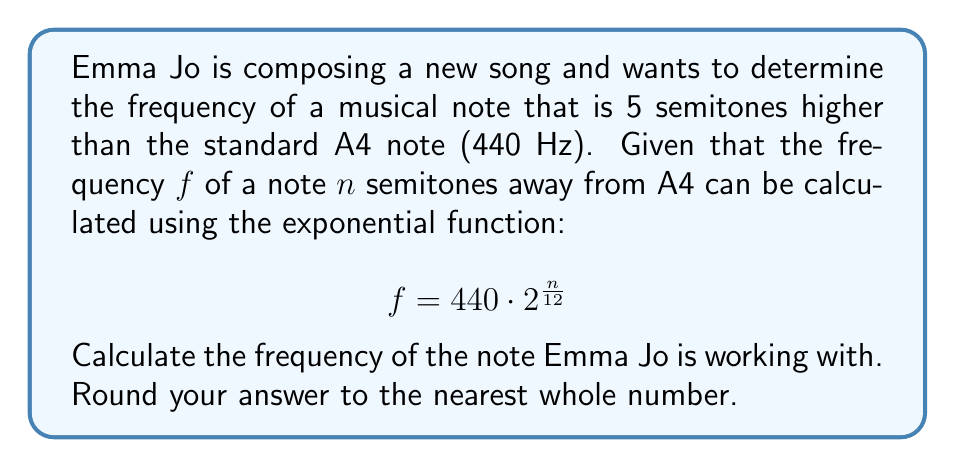Help me with this question. To solve this problem, we'll follow these steps:

1) We're given the exponential function for calculating the frequency:
   $$ f = 440 \cdot 2^{\frac{n}{12}} $$

2) We know that $n = 5$, as the note is 5 semitones higher than A4.

3) Let's substitute this value into our equation:
   $$ f = 440 \cdot 2^{\frac{5}{12}} $$

4) Now, let's calculate this step by step:
   
   a) First, let's calculate $\frac{5}{12}$:
      $\frac{5}{12} \approx 0.4166667$

   b) Now, let's calculate $2^{0.4166667}$:
      $2^{0.4166667} \approx 1.3348398$

   c) Finally, let's multiply this by 440:
      $440 \cdot 1.3348398 \approx 587.3295$

5) Rounding to the nearest whole number, we get 587 Hz.
Answer: 587 Hz 